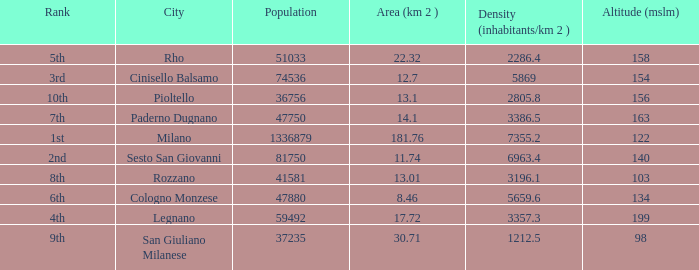Which Population is the highest one that has a Density (inhabitants/km 2) larger than 2805.8, and a Rank of 1st, and an Altitude (mslm) smaller than 122? None. 